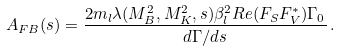Convert formula to latex. <formula><loc_0><loc_0><loc_500><loc_500>A _ { F B } ( s ) = \frac { 2 m _ { l } \lambda ( M _ { B } ^ { 2 } , M _ { K } ^ { 2 } , s ) \beta _ { l } ^ { 2 } R e ( F _ { S } F _ { V } ^ { * } ) \Gamma _ { 0 } } { d \Gamma / d s } \, .</formula> 